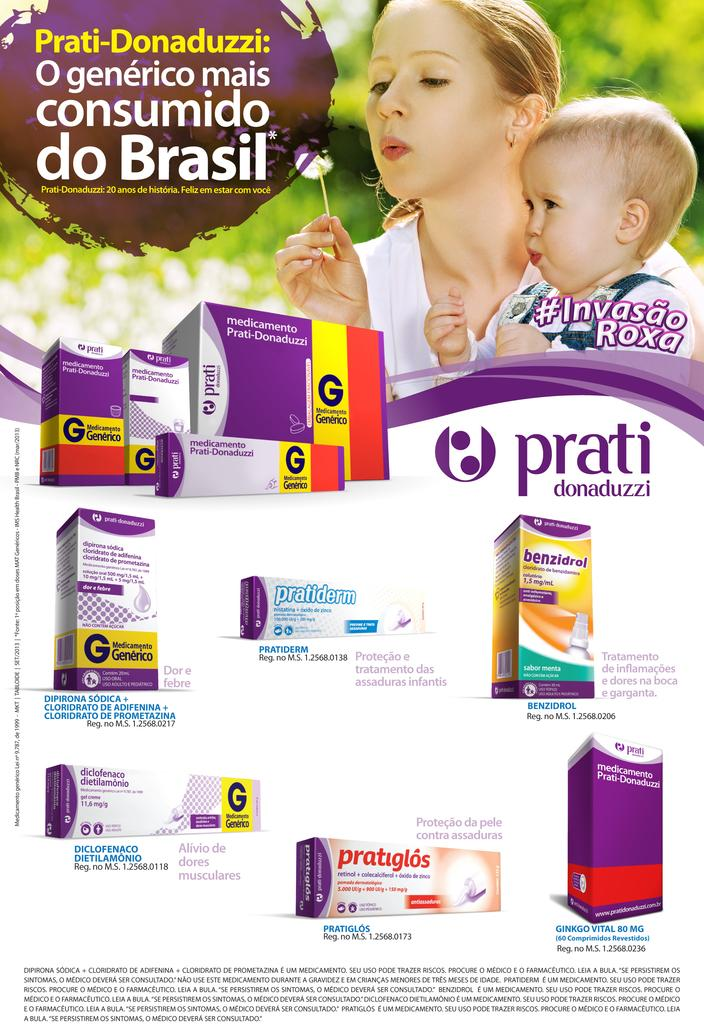<image>
Provide a brief description of the given image. a prati advertisement has a mom and her child blowing bubbles 